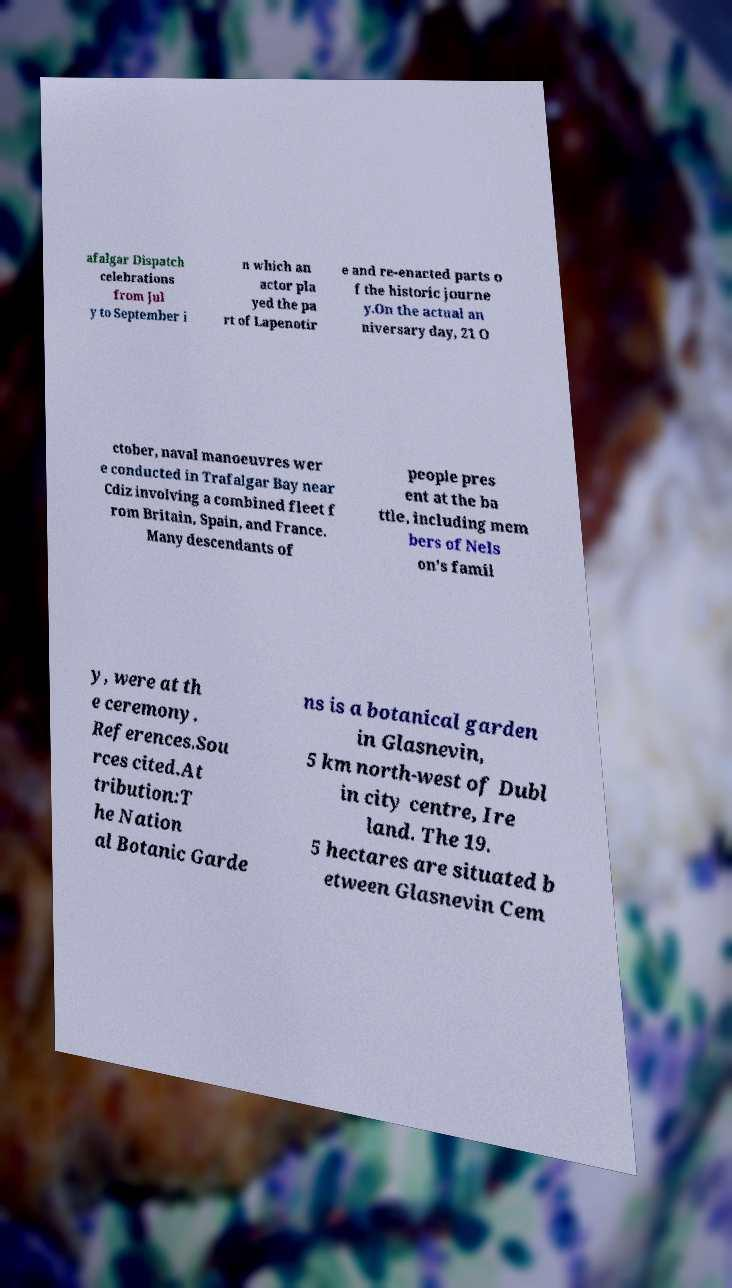Could you extract and type out the text from this image? afalgar Dispatch celebrations from Jul y to September i n which an actor pla yed the pa rt of Lapenotir e and re-enacted parts o f the historic journe y.On the actual an niversary day, 21 O ctober, naval manoeuvres wer e conducted in Trafalgar Bay near Cdiz involving a combined fleet f rom Britain, Spain, and France. Many descendants of people pres ent at the ba ttle, including mem bers of Nels on's famil y, were at th e ceremony. References.Sou rces cited.At tribution:T he Nation al Botanic Garde ns is a botanical garden in Glasnevin, 5 km north-west of Dubl in city centre, Ire land. The 19. 5 hectares are situated b etween Glasnevin Cem 